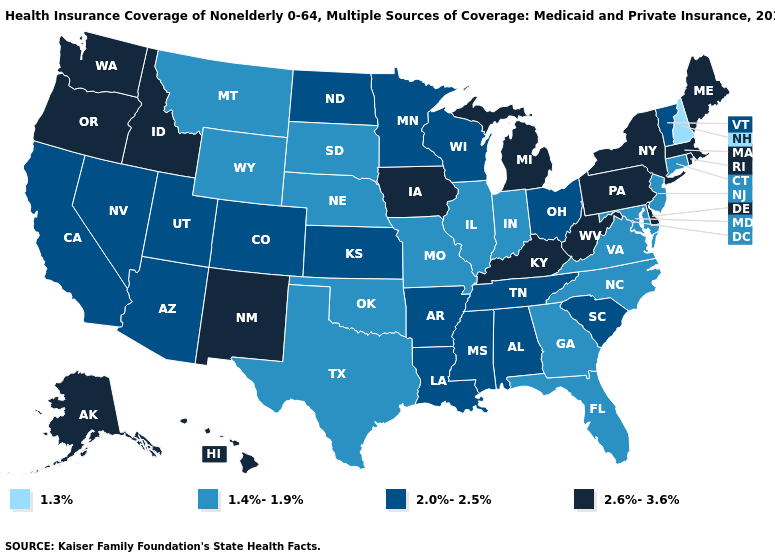Among the states that border Massachusetts , which have the lowest value?
Be succinct. New Hampshire. Name the states that have a value in the range 2.6%-3.6%?
Give a very brief answer. Alaska, Delaware, Hawaii, Idaho, Iowa, Kentucky, Maine, Massachusetts, Michigan, New Mexico, New York, Oregon, Pennsylvania, Rhode Island, Washington, West Virginia. Among the states that border Illinois , which have the highest value?
Short answer required. Iowa, Kentucky. Name the states that have a value in the range 2.0%-2.5%?
Short answer required. Alabama, Arizona, Arkansas, California, Colorado, Kansas, Louisiana, Minnesota, Mississippi, Nevada, North Dakota, Ohio, South Carolina, Tennessee, Utah, Vermont, Wisconsin. Which states have the lowest value in the Northeast?
Answer briefly. New Hampshire. How many symbols are there in the legend?
Keep it brief. 4. Does West Virginia have a higher value than Connecticut?
Concise answer only. Yes. Does Oregon have the highest value in the USA?
Answer briefly. Yes. Which states have the highest value in the USA?
Keep it brief. Alaska, Delaware, Hawaii, Idaho, Iowa, Kentucky, Maine, Massachusetts, Michigan, New Mexico, New York, Oregon, Pennsylvania, Rhode Island, Washington, West Virginia. Among the states that border Maryland , does Pennsylvania have the highest value?
Answer briefly. Yes. Name the states that have a value in the range 2.6%-3.6%?
Keep it brief. Alaska, Delaware, Hawaii, Idaho, Iowa, Kentucky, Maine, Massachusetts, Michigan, New Mexico, New York, Oregon, Pennsylvania, Rhode Island, Washington, West Virginia. How many symbols are there in the legend?
Give a very brief answer. 4. What is the value of Idaho?
Give a very brief answer. 2.6%-3.6%. Name the states that have a value in the range 2.0%-2.5%?
Keep it brief. Alabama, Arizona, Arkansas, California, Colorado, Kansas, Louisiana, Minnesota, Mississippi, Nevada, North Dakota, Ohio, South Carolina, Tennessee, Utah, Vermont, Wisconsin. Does Montana have a higher value than New Hampshire?
Quick response, please. Yes. 